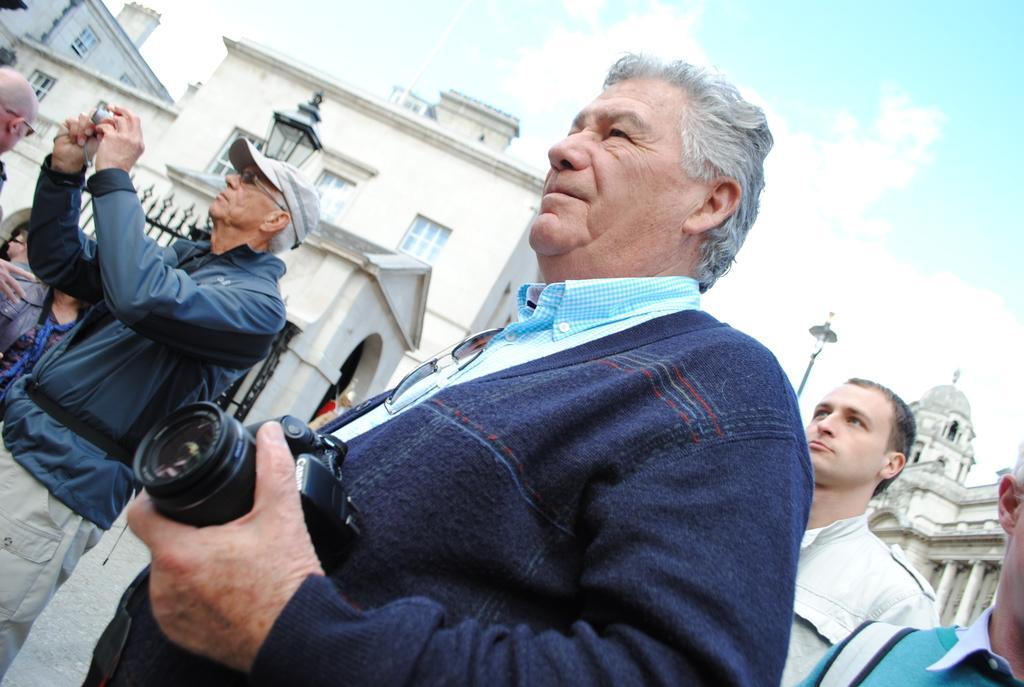Could you give a brief overview of what you see in this image? This is an outside view. Here I can see few people are standing on the road and looking towards the left side. I can see two men are wearing jackets and holding cameras in their hands. In the background, I can see the buildings. On the top of the image I can see the sky. 